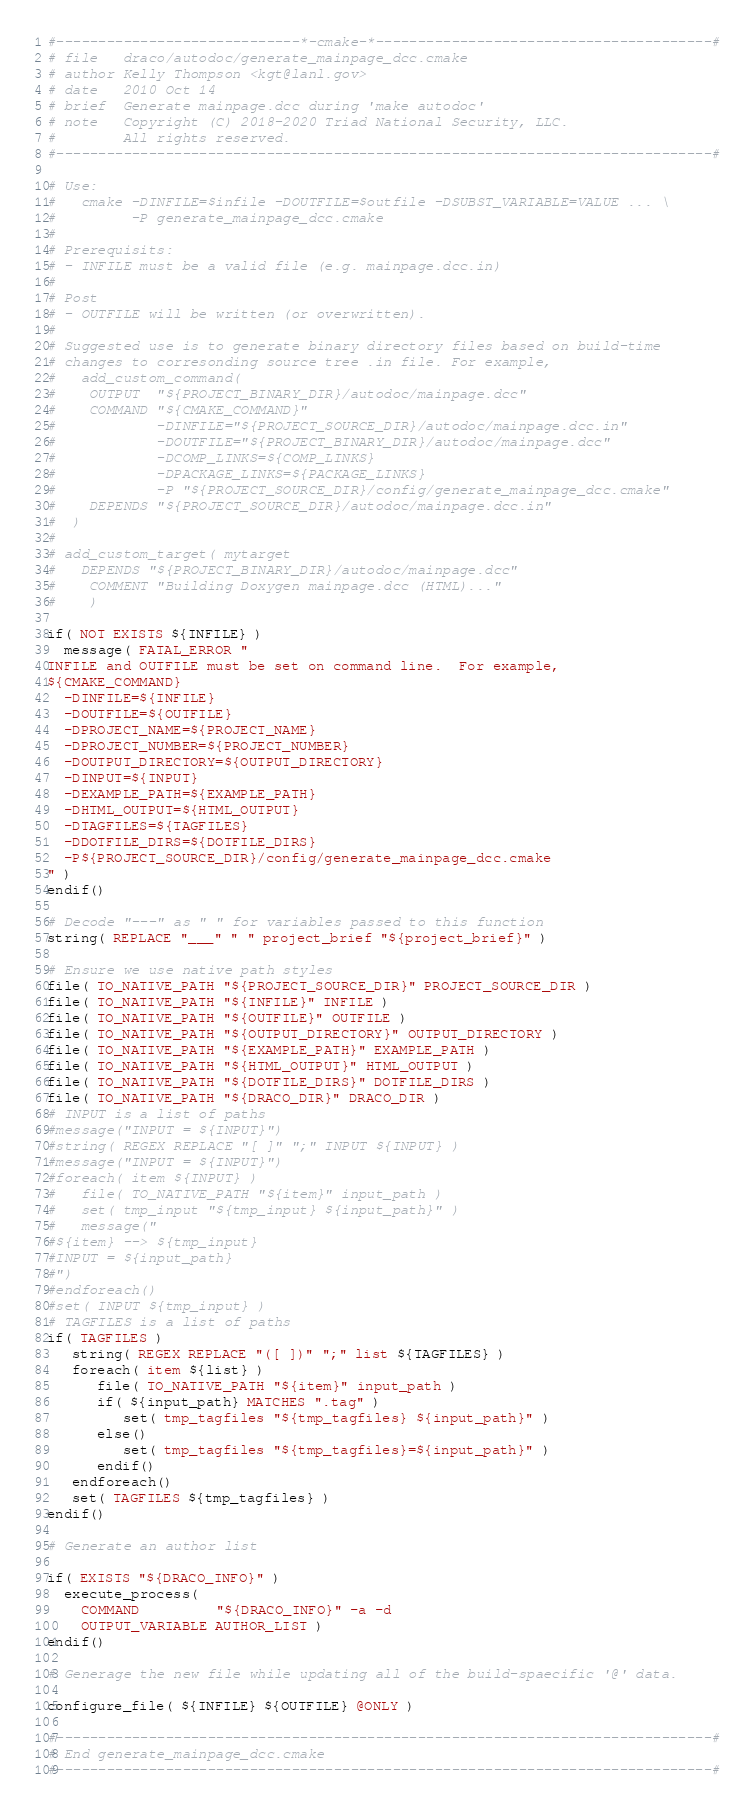Convert code to text. <code><loc_0><loc_0><loc_500><loc_500><_CMake_>#-----------------------------*-cmake-*----------------------------------------#
# file   draco/autodoc/generate_mainpage_dcc.cmake
# author Kelly Thompson <kgt@lanl.gov>
# date   2010 Oct 14
# brief  Generate mainpage.dcc during 'make autodoc'
# note   Copyright (C) 2018-2020 Triad National Security, LLC.
#        All rights reserved.
#------------------------------------------------------------------------------#

# Use:
#   cmake -DINFILE=$infile -DOUTFILE=$outfile -DSUBST_VARIABLE=VALUE ... \
#         -P generate_mainpage_dcc.cmake
#
# Prerequisits:
# - INFILE must be a valid file (e.g. mainpage.dcc.in)
#
# Post
# - OUTFILE will be written (or overwritten).
#
# Suggested use is to generate binary directory files based on build-time
# changes to corresonding source tree .in file. For example,
#   add_custom_command(
#    OUTPUT  "${PROJECT_BINARY_DIR}/autodoc/mainpage.dcc"
#    COMMAND "${CMAKE_COMMAND}"
#            -DINFILE="${PROJECT_SOURCE_DIR}/autodoc/mainpage.dcc.in"
#            -DOUTFILE="${PROJECT_BINARY_DIR}/autodoc/mainpage.dcc"
#            -DCOMP_LINKS=${COMP_LINKS}
#            -DPACKAGE_LINKS=${PACKAGE_LINKS}
#            -P "${PROJECT_SOURCE_DIR}/config/generate_mainpage_dcc.cmake"
#    DEPENDS "${PROJECT_SOURCE_DIR}/autodoc/mainpage.dcc.in"
#  )
#
# add_custom_target( mytarget
#   DEPENDS "${PROJECT_BINARY_DIR}/autodoc/mainpage.dcc"
#    COMMENT "Building Doxygen mainpage.dcc (HTML)..."
#    )

if( NOT EXISTS ${INFILE} )
  message( FATAL_ERROR "
INFILE and OUTFILE must be set on command line.  For example,
${CMAKE_COMMAND}
  -DINFILE=${INFILE}
  -DOUTFILE=${OUTFILE}
  -DPROJECT_NAME=${PROJECT_NAME}
  -DPROJECT_NUMBER=${PROJECT_NUMBER}
  -DOUTPUT_DIRECTORY=${OUTPUT_DIRECTORY}
  -DINPUT=${INPUT}
  -DEXAMPLE_PATH=${EXAMPLE_PATH}
  -DHTML_OUTPUT=${HTML_OUTPUT}
  -DTAGFILES=${TAGFILES}
  -DDOTFILE_DIRS=${DOTFILE_DIRS}
  -P${PROJECT_SOURCE_DIR}/config/generate_mainpage_dcc.cmake
" )
endif()

# Decode "---" as " " for variables passed to this function
string( REPLACE "___" " " project_brief "${project_brief}" )

# Ensure we use native path styles
file( TO_NATIVE_PATH "${PROJECT_SOURCE_DIR}" PROJECT_SOURCE_DIR )
file( TO_NATIVE_PATH "${INFILE}" INFILE )
file( TO_NATIVE_PATH "${OUTFILE}" OUTFILE )
file( TO_NATIVE_PATH "${OUTPUT_DIRECTORY}" OUTPUT_DIRECTORY )
file( TO_NATIVE_PATH "${EXAMPLE_PATH}" EXAMPLE_PATH )
file( TO_NATIVE_PATH "${HTML_OUTPUT}" HTML_OUTPUT )
file( TO_NATIVE_PATH "${DOTFILE_DIRS}" DOTFILE_DIRS )
file( TO_NATIVE_PATH "${DRACO_DIR}" DRACO_DIR )
# INPUT is a list of paths
#message("INPUT = ${INPUT}")
#string( REGEX REPLACE "[ ]" ";" INPUT ${INPUT} )
#message("INPUT = ${INPUT}")
#foreach( item ${INPUT} )
#   file( TO_NATIVE_PATH "${item}" input_path )
#   set( tmp_input "${tmp_input} ${input_path}" )
#   message("
#${item} --> ${tmp_input}
#INPUT = ${input_path}
#")
#endforeach()
#set( INPUT ${tmp_input} )
# TAGFILES is a list of paths
if( TAGFILES )
   string( REGEX REPLACE "([ ])" ";" list ${TAGFILES} )
   foreach( item ${list} )
      file( TO_NATIVE_PATH "${item}" input_path )
      if( ${input_path} MATCHES ".tag" )
         set( tmp_tagfiles "${tmp_tagfiles} ${input_path}" )
      else()
         set( tmp_tagfiles "${tmp_tagfiles}=${input_path}" )
      endif()
   endforeach()
   set( TAGFILES ${tmp_tagfiles} )
endif()

# Generate an author list

if( EXISTS "${DRACO_INFO}" )
  execute_process(
    COMMAND         "${DRACO_INFO}" -a -d
    OUTPUT_VARIABLE AUTHOR_LIST )
endif()

# Generage the new file while updating all of the build-spaecific '@' data.

configure_file( ${INFILE} ${OUTFILE} @ONLY )

#------------------------------------------------------------------------------#
# End generate_mainpage_dcc.cmake
#------------------------------------------------------------------------------#
</code> 